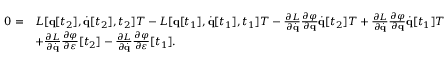Convert formula to latex. <formula><loc_0><loc_0><loc_500><loc_500>{ \begin{array} { r l } { 0 = } & { L [ q [ t _ { 2 } ] , { \dot { q } } [ t _ { 2 } ] , t _ { 2 } ] T - L [ q [ t _ { 1 } ] , { \dot { q } } [ t _ { 1 } ] , t _ { 1 } ] T - { \frac { \partial L } { \partial { \dot { q } } } } { \frac { \partial \varphi } { \partial q } } { \dot { q } } [ t _ { 2 } ] T + { \frac { \partial L } { \partial { \dot { q } } } } { \frac { \partial \varphi } { \partial q } } { \dot { q } } [ t _ { 1 } ] T } \\ & { + { \frac { \partial L } { \partial { \dot { q } } } } { \frac { \partial \varphi } { \partial \varepsilon } } [ t _ { 2 } ] - { \frac { \partial L } { \partial { \dot { q } } } } { \frac { \partial \varphi } { \partial \varepsilon } } [ t _ { 1 } ] . } \end{array} }</formula> 